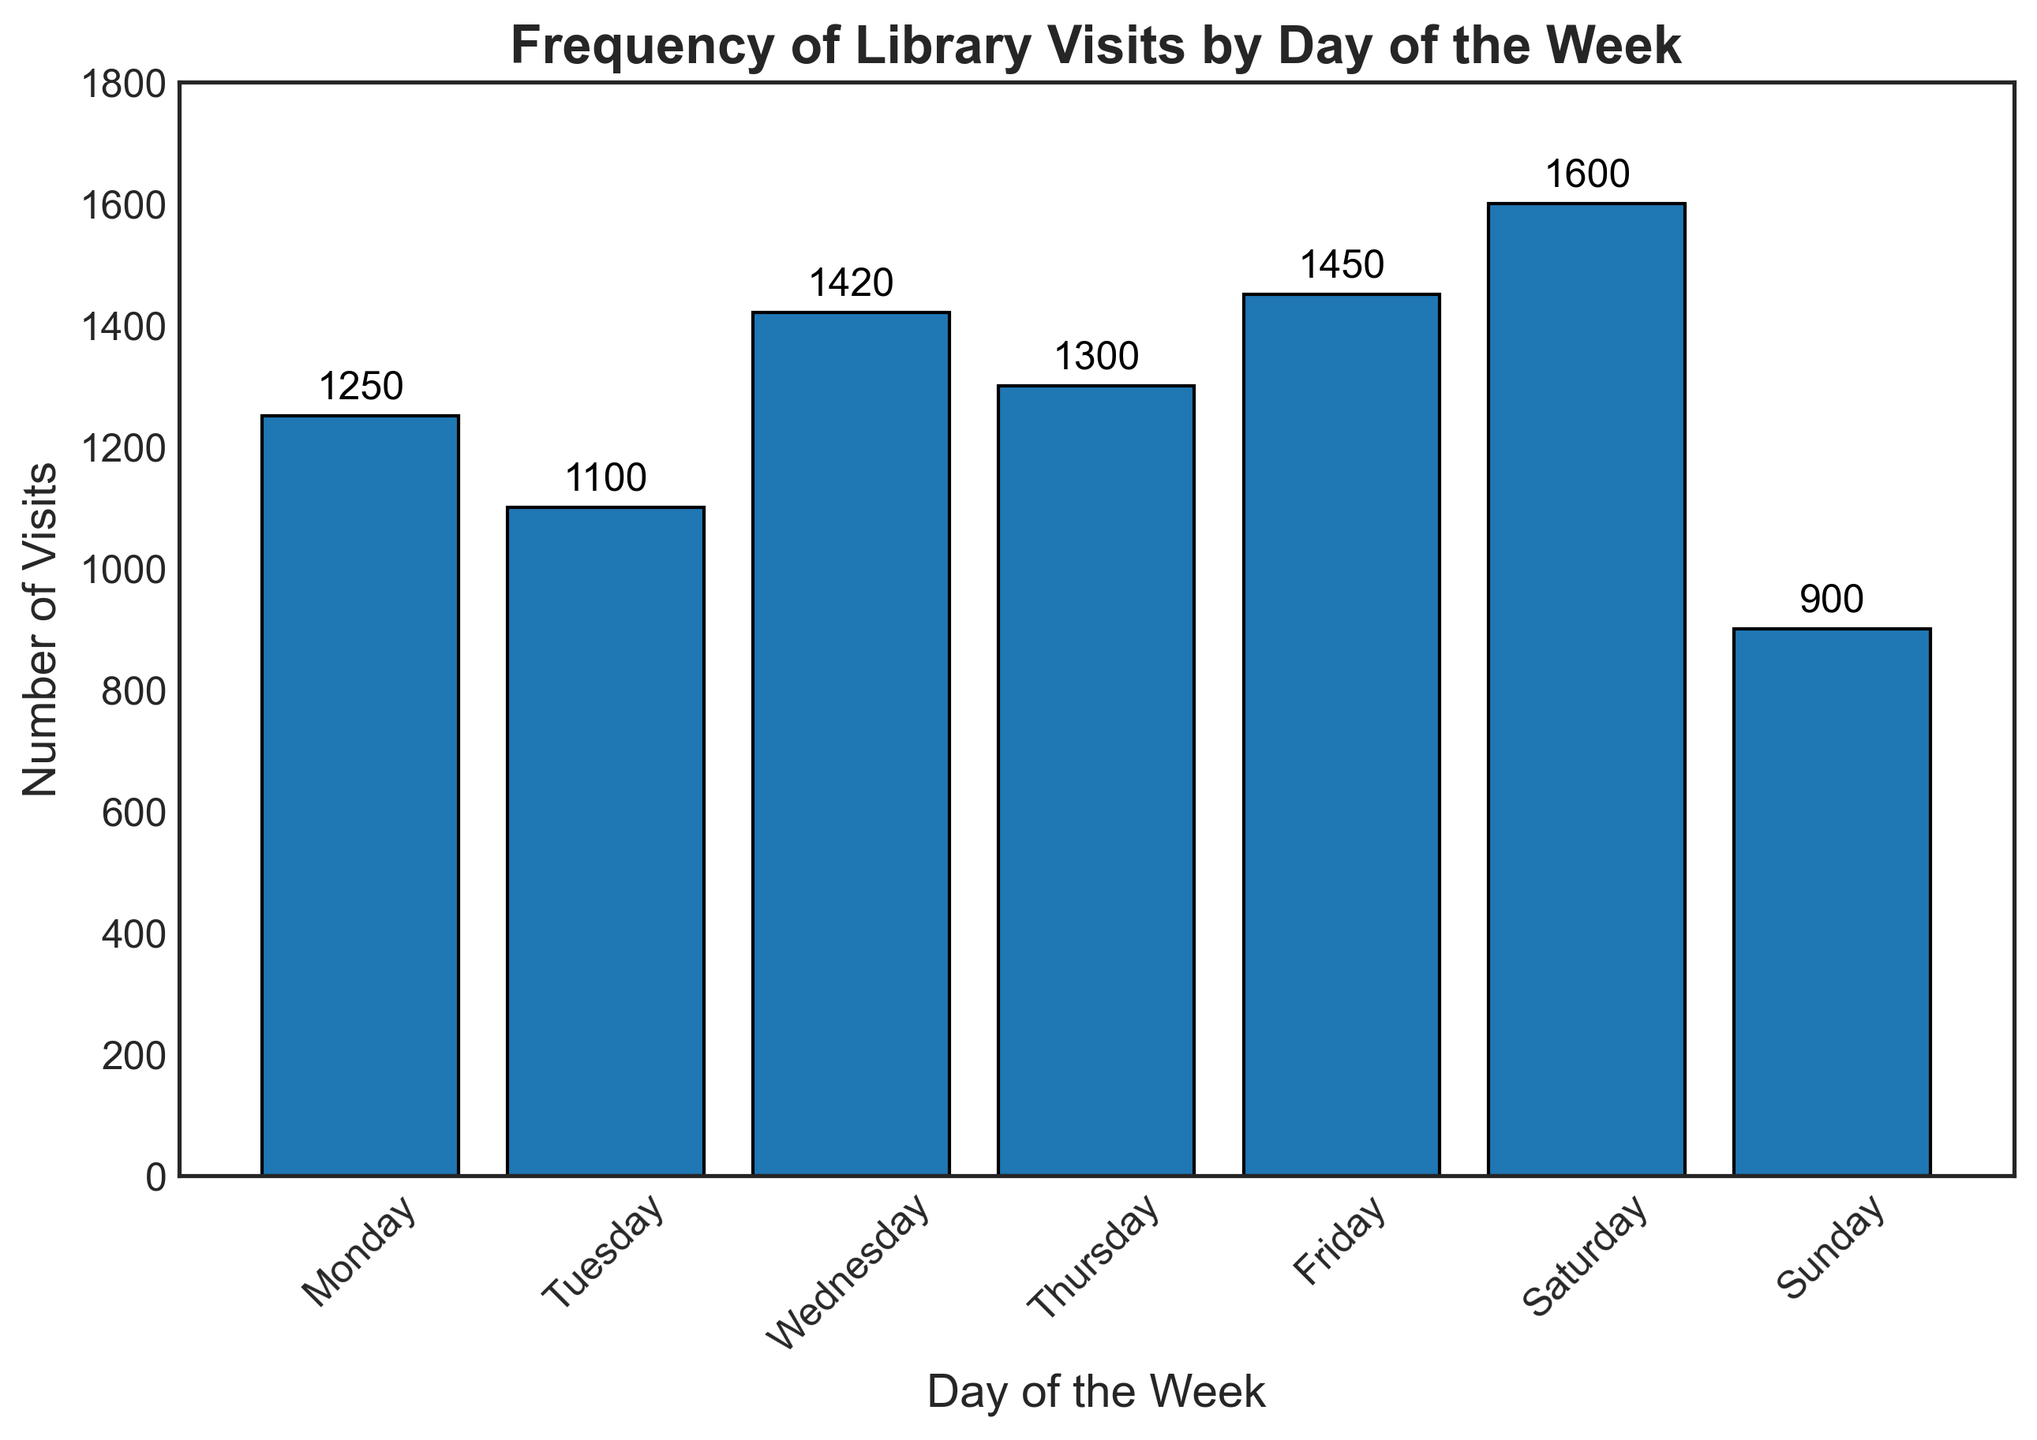What day has the highest frequency of library visits? Look at the tallest bar in the chart to find the day with the largest number, which is Saturday with 1600 visits.
Answer: Saturday What day has the lowest frequency of library visits? Look at the shortest bar in the chart to find the day with the smallest number, which is Sunday with 900 visits.
Answer: Sunday How many more visits are on Friday compared to Tuesday? Determine the frequency for both days (Friday with 1450 and Tuesday with 1100), then subtract Tuesday's visits from Friday's visits: 1450 - 1100 = 350.
Answer: 350 Which days have more than 1300 visits? Identify the days with frequencies above 1300 by looking at the bar heights for each day. The days are Wednesday (1420), Friday (1450), and Saturday (1600).
Answer: Wednesday, Friday, Saturday What is the average number of visits per day? Sum the total visits for all days (1250 + 1100 + 1420 + 1300 + 1450 + 1600 + 900 = 9020) and divide by the number of days (7): 9020 / 7 ≈ 1288.57.
Answer: 1288.57 Which day has the second highest frequency of visits? Identify the two highest bars and compare their frequencies. The highest is Saturday (1600), and the second highest is Friday (1450).
Answer: Friday What is the difference between the highest and lowest frequencies of visits? Subtract the smallest frequency (Sunday with 900) from the largest frequency (Saturday with 1600): 1600 - 900 = 700.
Answer: 700 How many total visits are there on weekends (Saturday and Sunday)? Sum the frequencies of Saturday (1600) and Sunday (900): 1600 + 900 = 2500.
Answer: 2500 What is the sum of visits from Monday, Wednesday, and Friday? Add the frequencies for Monday (1250), Wednesday (1420), and Friday (1450): 1250 + 1420 + 1450 = 4120.
Answer: 4120 How does the frequency of visits on Thursday compare to the average number of visits per day? First, find the average number of visits per day (1288.57). Compare Thursday's visits, which are 1300. Since 1300 is slightly above the average (1288.57), Thursday has a slightly higher number of visits than the average.
Answer: Higher 